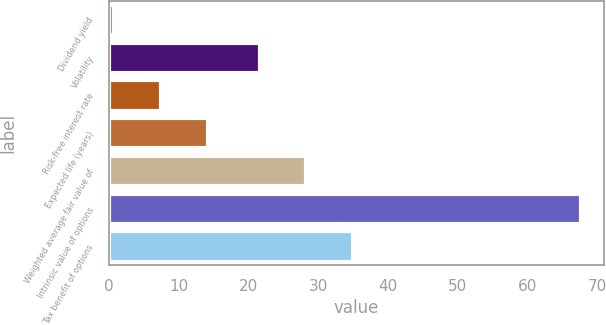<chart> <loc_0><loc_0><loc_500><loc_500><bar_chart><fcel>Dividend yield<fcel>Volatility<fcel>Risk-free interest rate<fcel>Expected life (years)<fcel>Weighted average fair value of<fcel>Intrinsic value of options<fcel>Tax benefit of options<nl><fcel>0.8<fcel>21.6<fcel>7.48<fcel>14.16<fcel>28.28<fcel>67.6<fcel>34.96<nl></chart> 